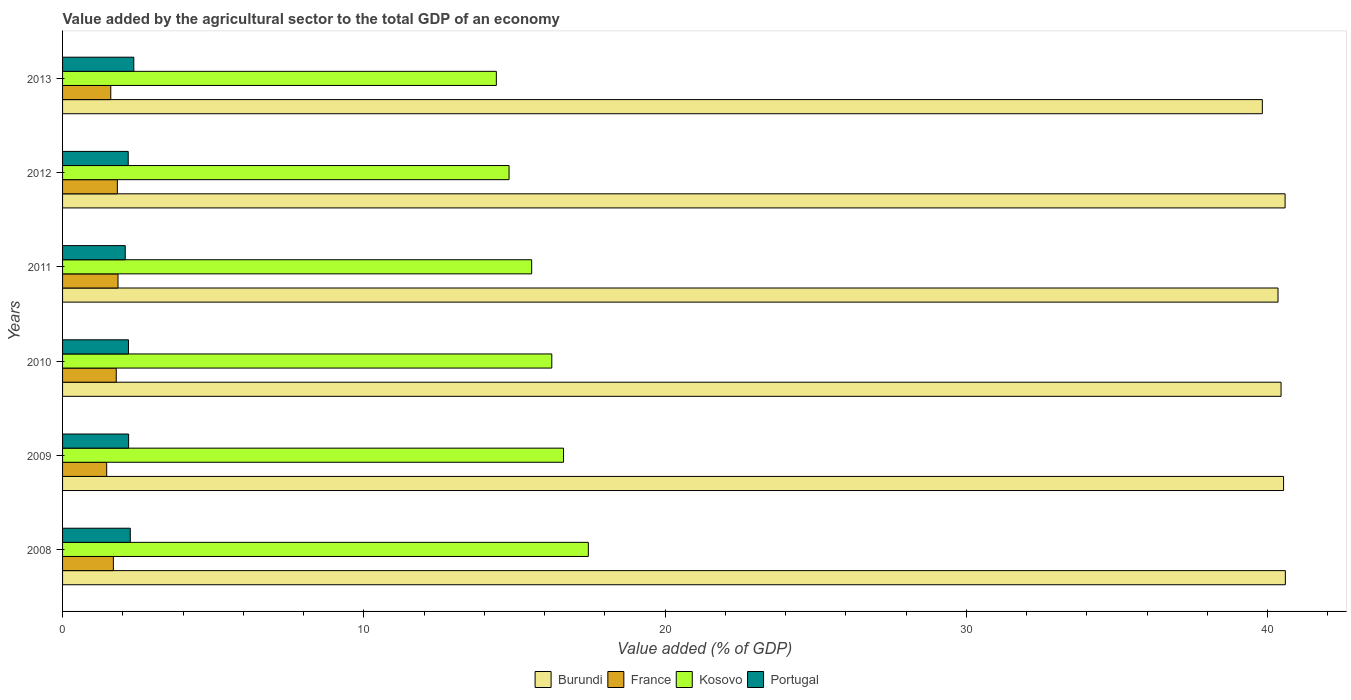How many groups of bars are there?
Give a very brief answer. 6. Are the number of bars on each tick of the Y-axis equal?
Your answer should be very brief. Yes. How many bars are there on the 4th tick from the bottom?
Your answer should be very brief. 4. In how many cases, is the number of bars for a given year not equal to the number of legend labels?
Offer a very short reply. 0. What is the value added by the agricultural sector to the total GDP in France in 2012?
Give a very brief answer. 1.82. Across all years, what is the maximum value added by the agricultural sector to the total GDP in France?
Give a very brief answer. 1.84. Across all years, what is the minimum value added by the agricultural sector to the total GDP in Portugal?
Keep it short and to the point. 2.08. What is the total value added by the agricultural sector to the total GDP in France in the graph?
Keep it short and to the point. 10.19. What is the difference between the value added by the agricultural sector to the total GDP in France in 2010 and that in 2012?
Keep it short and to the point. -0.04. What is the difference between the value added by the agricultural sector to the total GDP in Kosovo in 2010 and the value added by the agricultural sector to the total GDP in Burundi in 2013?
Give a very brief answer. -23.59. What is the average value added by the agricultural sector to the total GDP in Kosovo per year?
Provide a succinct answer. 15.85. In the year 2009, what is the difference between the value added by the agricultural sector to the total GDP in France and value added by the agricultural sector to the total GDP in Kosovo?
Your answer should be very brief. -15.17. In how many years, is the value added by the agricultural sector to the total GDP in Portugal greater than 8 %?
Your answer should be very brief. 0. What is the ratio of the value added by the agricultural sector to the total GDP in Kosovo in 2011 to that in 2012?
Ensure brevity in your answer.  1.05. Is the difference between the value added by the agricultural sector to the total GDP in France in 2008 and 2009 greater than the difference between the value added by the agricultural sector to the total GDP in Kosovo in 2008 and 2009?
Make the answer very short. No. What is the difference between the highest and the second highest value added by the agricultural sector to the total GDP in France?
Keep it short and to the point. 0.02. What is the difference between the highest and the lowest value added by the agricultural sector to the total GDP in France?
Provide a short and direct response. 0.38. In how many years, is the value added by the agricultural sector to the total GDP in Burundi greater than the average value added by the agricultural sector to the total GDP in Burundi taken over all years?
Provide a short and direct response. 4. Is the sum of the value added by the agricultural sector to the total GDP in Kosovo in 2009 and 2010 greater than the maximum value added by the agricultural sector to the total GDP in Portugal across all years?
Make the answer very short. Yes. What does the 4th bar from the top in 2013 represents?
Your answer should be compact. Burundi. Is it the case that in every year, the sum of the value added by the agricultural sector to the total GDP in Portugal and value added by the agricultural sector to the total GDP in France is greater than the value added by the agricultural sector to the total GDP in Burundi?
Your response must be concise. No. How many bars are there?
Keep it short and to the point. 24. How many years are there in the graph?
Provide a succinct answer. 6. What is the difference between two consecutive major ticks on the X-axis?
Give a very brief answer. 10. Does the graph contain any zero values?
Make the answer very short. No. How are the legend labels stacked?
Provide a short and direct response. Horizontal. What is the title of the graph?
Your response must be concise. Value added by the agricultural sector to the total GDP of an economy. Does "St. Vincent and the Grenadines" appear as one of the legend labels in the graph?
Provide a short and direct response. No. What is the label or title of the X-axis?
Ensure brevity in your answer.  Value added (% of GDP). What is the Value added (% of GDP) in Burundi in 2008?
Ensure brevity in your answer.  40.59. What is the Value added (% of GDP) in France in 2008?
Provide a short and direct response. 1.69. What is the Value added (% of GDP) in Kosovo in 2008?
Make the answer very short. 17.45. What is the Value added (% of GDP) of Portugal in 2008?
Your answer should be compact. 2.25. What is the Value added (% of GDP) in Burundi in 2009?
Make the answer very short. 40.53. What is the Value added (% of GDP) in France in 2009?
Ensure brevity in your answer.  1.46. What is the Value added (% of GDP) of Kosovo in 2009?
Give a very brief answer. 16.63. What is the Value added (% of GDP) of Portugal in 2009?
Provide a short and direct response. 2.19. What is the Value added (% of GDP) in Burundi in 2010?
Offer a terse response. 40.45. What is the Value added (% of GDP) in France in 2010?
Keep it short and to the point. 1.78. What is the Value added (% of GDP) of Kosovo in 2010?
Your response must be concise. 16.24. What is the Value added (% of GDP) of Portugal in 2010?
Provide a succinct answer. 2.19. What is the Value added (% of GDP) of Burundi in 2011?
Ensure brevity in your answer.  40.35. What is the Value added (% of GDP) in France in 2011?
Offer a terse response. 1.84. What is the Value added (% of GDP) in Kosovo in 2011?
Keep it short and to the point. 15.57. What is the Value added (% of GDP) in Portugal in 2011?
Keep it short and to the point. 2.08. What is the Value added (% of GDP) of Burundi in 2012?
Offer a very short reply. 40.58. What is the Value added (% of GDP) in France in 2012?
Provide a succinct answer. 1.82. What is the Value added (% of GDP) in Kosovo in 2012?
Give a very brief answer. 14.82. What is the Value added (% of GDP) in Portugal in 2012?
Keep it short and to the point. 2.18. What is the Value added (% of GDP) in Burundi in 2013?
Make the answer very short. 39.83. What is the Value added (% of GDP) in France in 2013?
Keep it short and to the point. 1.6. What is the Value added (% of GDP) of Kosovo in 2013?
Your answer should be very brief. 14.4. What is the Value added (% of GDP) of Portugal in 2013?
Your answer should be very brief. 2.37. Across all years, what is the maximum Value added (% of GDP) in Burundi?
Provide a short and direct response. 40.59. Across all years, what is the maximum Value added (% of GDP) in France?
Ensure brevity in your answer.  1.84. Across all years, what is the maximum Value added (% of GDP) of Kosovo?
Provide a succinct answer. 17.45. Across all years, what is the maximum Value added (% of GDP) of Portugal?
Keep it short and to the point. 2.37. Across all years, what is the minimum Value added (% of GDP) in Burundi?
Offer a very short reply. 39.83. Across all years, what is the minimum Value added (% of GDP) of France?
Make the answer very short. 1.46. Across all years, what is the minimum Value added (% of GDP) of Kosovo?
Offer a very short reply. 14.4. Across all years, what is the minimum Value added (% of GDP) of Portugal?
Make the answer very short. 2.08. What is the total Value added (% of GDP) of Burundi in the graph?
Offer a terse response. 242.33. What is the total Value added (% of GDP) of France in the graph?
Offer a terse response. 10.19. What is the total Value added (% of GDP) in Kosovo in the graph?
Make the answer very short. 95.12. What is the total Value added (% of GDP) in Portugal in the graph?
Keep it short and to the point. 13.25. What is the difference between the Value added (% of GDP) of Burundi in 2008 and that in 2009?
Give a very brief answer. 0.06. What is the difference between the Value added (% of GDP) of France in 2008 and that in 2009?
Ensure brevity in your answer.  0.22. What is the difference between the Value added (% of GDP) of Kosovo in 2008 and that in 2009?
Your answer should be compact. 0.82. What is the difference between the Value added (% of GDP) in Portugal in 2008 and that in 2009?
Keep it short and to the point. 0.06. What is the difference between the Value added (% of GDP) of Burundi in 2008 and that in 2010?
Offer a very short reply. 0.14. What is the difference between the Value added (% of GDP) in France in 2008 and that in 2010?
Offer a very short reply. -0.1. What is the difference between the Value added (% of GDP) in Kosovo in 2008 and that in 2010?
Ensure brevity in your answer.  1.21. What is the difference between the Value added (% of GDP) of Portugal in 2008 and that in 2010?
Keep it short and to the point. 0.06. What is the difference between the Value added (% of GDP) in Burundi in 2008 and that in 2011?
Provide a succinct answer. 0.24. What is the difference between the Value added (% of GDP) of France in 2008 and that in 2011?
Ensure brevity in your answer.  -0.15. What is the difference between the Value added (% of GDP) in Kosovo in 2008 and that in 2011?
Provide a short and direct response. 1.88. What is the difference between the Value added (% of GDP) in Portugal in 2008 and that in 2011?
Provide a succinct answer. 0.17. What is the difference between the Value added (% of GDP) of Burundi in 2008 and that in 2012?
Provide a succinct answer. 0.01. What is the difference between the Value added (% of GDP) in France in 2008 and that in 2012?
Ensure brevity in your answer.  -0.13. What is the difference between the Value added (% of GDP) in Kosovo in 2008 and that in 2012?
Offer a terse response. 2.63. What is the difference between the Value added (% of GDP) of Portugal in 2008 and that in 2012?
Give a very brief answer. 0.07. What is the difference between the Value added (% of GDP) in Burundi in 2008 and that in 2013?
Make the answer very short. 0.76. What is the difference between the Value added (% of GDP) of France in 2008 and that in 2013?
Your answer should be very brief. 0.09. What is the difference between the Value added (% of GDP) in Kosovo in 2008 and that in 2013?
Give a very brief answer. 3.05. What is the difference between the Value added (% of GDP) of Portugal in 2008 and that in 2013?
Keep it short and to the point. -0.12. What is the difference between the Value added (% of GDP) of Burundi in 2009 and that in 2010?
Your answer should be compact. 0.08. What is the difference between the Value added (% of GDP) of France in 2009 and that in 2010?
Your answer should be very brief. -0.32. What is the difference between the Value added (% of GDP) in Kosovo in 2009 and that in 2010?
Provide a short and direct response. 0.39. What is the difference between the Value added (% of GDP) in Portugal in 2009 and that in 2010?
Give a very brief answer. 0. What is the difference between the Value added (% of GDP) of Burundi in 2009 and that in 2011?
Offer a terse response. 0.18. What is the difference between the Value added (% of GDP) of France in 2009 and that in 2011?
Ensure brevity in your answer.  -0.38. What is the difference between the Value added (% of GDP) of Kosovo in 2009 and that in 2011?
Your answer should be very brief. 1.06. What is the difference between the Value added (% of GDP) of Portugal in 2009 and that in 2011?
Ensure brevity in your answer.  0.11. What is the difference between the Value added (% of GDP) in Burundi in 2009 and that in 2012?
Give a very brief answer. -0.05. What is the difference between the Value added (% of GDP) of France in 2009 and that in 2012?
Your response must be concise. -0.35. What is the difference between the Value added (% of GDP) in Kosovo in 2009 and that in 2012?
Your answer should be very brief. 1.81. What is the difference between the Value added (% of GDP) of Portugal in 2009 and that in 2012?
Provide a short and direct response. 0.01. What is the difference between the Value added (% of GDP) of Burundi in 2009 and that in 2013?
Provide a succinct answer. 0.7. What is the difference between the Value added (% of GDP) of France in 2009 and that in 2013?
Your response must be concise. -0.14. What is the difference between the Value added (% of GDP) in Kosovo in 2009 and that in 2013?
Provide a succinct answer. 2.23. What is the difference between the Value added (% of GDP) of Portugal in 2009 and that in 2013?
Your answer should be compact. -0.17. What is the difference between the Value added (% of GDP) of Burundi in 2010 and that in 2011?
Offer a very short reply. 0.1. What is the difference between the Value added (% of GDP) in France in 2010 and that in 2011?
Offer a terse response. -0.06. What is the difference between the Value added (% of GDP) in Kosovo in 2010 and that in 2011?
Your answer should be very brief. 0.67. What is the difference between the Value added (% of GDP) in Portugal in 2010 and that in 2011?
Keep it short and to the point. 0.11. What is the difference between the Value added (% of GDP) in Burundi in 2010 and that in 2012?
Your answer should be compact. -0.13. What is the difference between the Value added (% of GDP) of France in 2010 and that in 2012?
Make the answer very short. -0.04. What is the difference between the Value added (% of GDP) in Kosovo in 2010 and that in 2012?
Give a very brief answer. 1.42. What is the difference between the Value added (% of GDP) of Portugal in 2010 and that in 2012?
Your answer should be very brief. 0.01. What is the difference between the Value added (% of GDP) of Burundi in 2010 and that in 2013?
Provide a succinct answer. 0.62. What is the difference between the Value added (% of GDP) in France in 2010 and that in 2013?
Ensure brevity in your answer.  0.18. What is the difference between the Value added (% of GDP) of Kosovo in 2010 and that in 2013?
Your answer should be very brief. 1.84. What is the difference between the Value added (% of GDP) of Portugal in 2010 and that in 2013?
Make the answer very short. -0.18. What is the difference between the Value added (% of GDP) in Burundi in 2011 and that in 2012?
Give a very brief answer. -0.23. What is the difference between the Value added (% of GDP) in France in 2011 and that in 2012?
Your answer should be very brief. 0.02. What is the difference between the Value added (% of GDP) of Kosovo in 2011 and that in 2012?
Provide a short and direct response. 0.75. What is the difference between the Value added (% of GDP) of Portugal in 2011 and that in 2012?
Ensure brevity in your answer.  -0.1. What is the difference between the Value added (% of GDP) in Burundi in 2011 and that in 2013?
Offer a terse response. 0.52. What is the difference between the Value added (% of GDP) of France in 2011 and that in 2013?
Make the answer very short. 0.24. What is the difference between the Value added (% of GDP) of Kosovo in 2011 and that in 2013?
Ensure brevity in your answer.  1.17. What is the difference between the Value added (% of GDP) in Portugal in 2011 and that in 2013?
Give a very brief answer. -0.28. What is the difference between the Value added (% of GDP) of Burundi in 2012 and that in 2013?
Make the answer very short. 0.76. What is the difference between the Value added (% of GDP) of France in 2012 and that in 2013?
Offer a terse response. 0.22. What is the difference between the Value added (% of GDP) in Kosovo in 2012 and that in 2013?
Ensure brevity in your answer.  0.42. What is the difference between the Value added (% of GDP) of Portugal in 2012 and that in 2013?
Keep it short and to the point. -0.19. What is the difference between the Value added (% of GDP) of Burundi in 2008 and the Value added (% of GDP) of France in 2009?
Make the answer very short. 39.13. What is the difference between the Value added (% of GDP) of Burundi in 2008 and the Value added (% of GDP) of Kosovo in 2009?
Ensure brevity in your answer.  23.96. What is the difference between the Value added (% of GDP) of Burundi in 2008 and the Value added (% of GDP) of Portugal in 2009?
Your answer should be very brief. 38.4. What is the difference between the Value added (% of GDP) of France in 2008 and the Value added (% of GDP) of Kosovo in 2009?
Offer a very short reply. -14.94. What is the difference between the Value added (% of GDP) of France in 2008 and the Value added (% of GDP) of Portugal in 2009?
Your answer should be very brief. -0.51. What is the difference between the Value added (% of GDP) of Kosovo in 2008 and the Value added (% of GDP) of Portugal in 2009?
Make the answer very short. 15.26. What is the difference between the Value added (% of GDP) of Burundi in 2008 and the Value added (% of GDP) of France in 2010?
Keep it short and to the point. 38.81. What is the difference between the Value added (% of GDP) in Burundi in 2008 and the Value added (% of GDP) in Kosovo in 2010?
Offer a very short reply. 24.35. What is the difference between the Value added (% of GDP) in Burundi in 2008 and the Value added (% of GDP) in Portugal in 2010?
Keep it short and to the point. 38.4. What is the difference between the Value added (% of GDP) of France in 2008 and the Value added (% of GDP) of Kosovo in 2010?
Ensure brevity in your answer.  -14.55. What is the difference between the Value added (% of GDP) in France in 2008 and the Value added (% of GDP) in Portugal in 2010?
Make the answer very short. -0.5. What is the difference between the Value added (% of GDP) in Kosovo in 2008 and the Value added (% of GDP) in Portugal in 2010?
Offer a very short reply. 15.27. What is the difference between the Value added (% of GDP) of Burundi in 2008 and the Value added (% of GDP) of France in 2011?
Keep it short and to the point. 38.75. What is the difference between the Value added (% of GDP) of Burundi in 2008 and the Value added (% of GDP) of Kosovo in 2011?
Provide a short and direct response. 25.02. What is the difference between the Value added (% of GDP) of Burundi in 2008 and the Value added (% of GDP) of Portugal in 2011?
Give a very brief answer. 38.51. What is the difference between the Value added (% of GDP) of France in 2008 and the Value added (% of GDP) of Kosovo in 2011?
Offer a very short reply. -13.89. What is the difference between the Value added (% of GDP) in France in 2008 and the Value added (% of GDP) in Portugal in 2011?
Your response must be concise. -0.39. What is the difference between the Value added (% of GDP) in Kosovo in 2008 and the Value added (% of GDP) in Portugal in 2011?
Ensure brevity in your answer.  15.37. What is the difference between the Value added (% of GDP) of Burundi in 2008 and the Value added (% of GDP) of France in 2012?
Offer a terse response. 38.77. What is the difference between the Value added (% of GDP) of Burundi in 2008 and the Value added (% of GDP) of Kosovo in 2012?
Make the answer very short. 25.77. What is the difference between the Value added (% of GDP) in Burundi in 2008 and the Value added (% of GDP) in Portugal in 2012?
Keep it short and to the point. 38.41. What is the difference between the Value added (% of GDP) in France in 2008 and the Value added (% of GDP) in Kosovo in 2012?
Offer a terse response. -13.13. What is the difference between the Value added (% of GDP) of France in 2008 and the Value added (% of GDP) of Portugal in 2012?
Your response must be concise. -0.49. What is the difference between the Value added (% of GDP) of Kosovo in 2008 and the Value added (% of GDP) of Portugal in 2012?
Offer a terse response. 15.27. What is the difference between the Value added (% of GDP) of Burundi in 2008 and the Value added (% of GDP) of France in 2013?
Provide a succinct answer. 38.99. What is the difference between the Value added (% of GDP) of Burundi in 2008 and the Value added (% of GDP) of Kosovo in 2013?
Ensure brevity in your answer.  26.19. What is the difference between the Value added (% of GDP) of Burundi in 2008 and the Value added (% of GDP) of Portugal in 2013?
Offer a very short reply. 38.23. What is the difference between the Value added (% of GDP) of France in 2008 and the Value added (% of GDP) of Kosovo in 2013?
Give a very brief answer. -12.71. What is the difference between the Value added (% of GDP) of France in 2008 and the Value added (% of GDP) of Portugal in 2013?
Offer a very short reply. -0.68. What is the difference between the Value added (% of GDP) in Kosovo in 2008 and the Value added (% of GDP) in Portugal in 2013?
Make the answer very short. 15.09. What is the difference between the Value added (% of GDP) in Burundi in 2009 and the Value added (% of GDP) in France in 2010?
Your answer should be very brief. 38.75. What is the difference between the Value added (% of GDP) of Burundi in 2009 and the Value added (% of GDP) of Kosovo in 2010?
Keep it short and to the point. 24.29. What is the difference between the Value added (% of GDP) in Burundi in 2009 and the Value added (% of GDP) in Portugal in 2010?
Provide a short and direct response. 38.34. What is the difference between the Value added (% of GDP) in France in 2009 and the Value added (% of GDP) in Kosovo in 2010?
Keep it short and to the point. -14.78. What is the difference between the Value added (% of GDP) in France in 2009 and the Value added (% of GDP) in Portugal in 2010?
Your response must be concise. -0.72. What is the difference between the Value added (% of GDP) in Kosovo in 2009 and the Value added (% of GDP) in Portugal in 2010?
Your answer should be very brief. 14.44. What is the difference between the Value added (% of GDP) in Burundi in 2009 and the Value added (% of GDP) in France in 2011?
Your answer should be very brief. 38.69. What is the difference between the Value added (% of GDP) in Burundi in 2009 and the Value added (% of GDP) in Kosovo in 2011?
Provide a short and direct response. 24.96. What is the difference between the Value added (% of GDP) in Burundi in 2009 and the Value added (% of GDP) in Portugal in 2011?
Ensure brevity in your answer.  38.45. What is the difference between the Value added (% of GDP) of France in 2009 and the Value added (% of GDP) of Kosovo in 2011?
Provide a short and direct response. -14.11. What is the difference between the Value added (% of GDP) in France in 2009 and the Value added (% of GDP) in Portugal in 2011?
Offer a very short reply. -0.62. What is the difference between the Value added (% of GDP) of Kosovo in 2009 and the Value added (% of GDP) of Portugal in 2011?
Give a very brief answer. 14.55. What is the difference between the Value added (% of GDP) in Burundi in 2009 and the Value added (% of GDP) in France in 2012?
Offer a terse response. 38.71. What is the difference between the Value added (% of GDP) in Burundi in 2009 and the Value added (% of GDP) in Kosovo in 2012?
Your answer should be compact. 25.71. What is the difference between the Value added (% of GDP) of Burundi in 2009 and the Value added (% of GDP) of Portugal in 2012?
Offer a very short reply. 38.35. What is the difference between the Value added (% of GDP) in France in 2009 and the Value added (% of GDP) in Kosovo in 2012?
Your response must be concise. -13.36. What is the difference between the Value added (% of GDP) of France in 2009 and the Value added (% of GDP) of Portugal in 2012?
Make the answer very short. -0.71. What is the difference between the Value added (% of GDP) of Kosovo in 2009 and the Value added (% of GDP) of Portugal in 2012?
Ensure brevity in your answer.  14.45. What is the difference between the Value added (% of GDP) of Burundi in 2009 and the Value added (% of GDP) of France in 2013?
Your answer should be compact. 38.93. What is the difference between the Value added (% of GDP) in Burundi in 2009 and the Value added (% of GDP) in Kosovo in 2013?
Your answer should be compact. 26.13. What is the difference between the Value added (% of GDP) in Burundi in 2009 and the Value added (% of GDP) in Portugal in 2013?
Ensure brevity in your answer.  38.17. What is the difference between the Value added (% of GDP) of France in 2009 and the Value added (% of GDP) of Kosovo in 2013?
Provide a succinct answer. -12.93. What is the difference between the Value added (% of GDP) of France in 2009 and the Value added (% of GDP) of Portugal in 2013?
Offer a terse response. -0.9. What is the difference between the Value added (% of GDP) of Kosovo in 2009 and the Value added (% of GDP) of Portugal in 2013?
Provide a short and direct response. 14.26. What is the difference between the Value added (% of GDP) in Burundi in 2010 and the Value added (% of GDP) in France in 2011?
Keep it short and to the point. 38.61. What is the difference between the Value added (% of GDP) in Burundi in 2010 and the Value added (% of GDP) in Kosovo in 2011?
Make the answer very short. 24.88. What is the difference between the Value added (% of GDP) of Burundi in 2010 and the Value added (% of GDP) of Portugal in 2011?
Ensure brevity in your answer.  38.37. What is the difference between the Value added (% of GDP) of France in 2010 and the Value added (% of GDP) of Kosovo in 2011?
Offer a very short reply. -13.79. What is the difference between the Value added (% of GDP) in France in 2010 and the Value added (% of GDP) in Portugal in 2011?
Give a very brief answer. -0.3. What is the difference between the Value added (% of GDP) in Kosovo in 2010 and the Value added (% of GDP) in Portugal in 2011?
Give a very brief answer. 14.16. What is the difference between the Value added (% of GDP) of Burundi in 2010 and the Value added (% of GDP) of France in 2012?
Provide a succinct answer. 38.63. What is the difference between the Value added (% of GDP) in Burundi in 2010 and the Value added (% of GDP) in Kosovo in 2012?
Ensure brevity in your answer.  25.63. What is the difference between the Value added (% of GDP) in Burundi in 2010 and the Value added (% of GDP) in Portugal in 2012?
Ensure brevity in your answer.  38.27. What is the difference between the Value added (% of GDP) of France in 2010 and the Value added (% of GDP) of Kosovo in 2012?
Your response must be concise. -13.04. What is the difference between the Value added (% of GDP) of France in 2010 and the Value added (% of GDP) of Portugal in 2012?
Your answer should be compact. -0.4. What is the difference between the Value added (% of GDP) in Kosovo in 2010 and the Value added (% of GDP) in Portugal in 2012?
Offer a terse response. 14.06. What is the difference between the Value added (% of GDP) in Burundi in 2010 and the Value added (% of GDP) in France in 2013?
Offer a very short reply. 38.85. What is the difference between the Value added (% of GDP) of Burundi in 2010 and the Value added (% of GDP) of Kosovo in 2013?
Ensure brevity in your answer.  26.05. What is the difference between the Value added (% of GDP) of Burundi in 2010 and the Value added (% of GDP) of Portugal in 2013?
Ensure brevity in your answer.  38.08. What is the difference between the Value added (% of GDP) in France in 2010 and the Value added (% of GDP) in Kosovo in 2013?
Provide a succinct answer. -12.62. What is the difference between the Value added (% of GDP) of France in 2010 and the Value added (% of GDP) of Portugal in 2013?
Keep it short and to the point. -0.58. What is the difference between the Value added (% of GDP) in Kosovo in 2010 and the Value added (% of GDP) in Portugal in 2013?
Ensure brevity in your answer.  13.88. What is the difference between the Value added (% of GDP) of Burundi in 2011 and the Value added (% of GDP) of France in 2012?
Ensure brevity in your answer.  38.53. What is the difference between the Value added (% of GDP) of Burundi in 2011 and the Value added (% of GDP) of Kosovo in 2012?
Give a very brief answer. 25.53. What is the difference between the Value added (% of GDP) in Burundi in 2011 and the Value added (% of GDP) in Portugal in 2012?
Make the answer very short. 38.17. What is the difference between the Value added (% of GDP) of France in 2011 and the Value added (% of GDP) of Kosovo in 2012?
Provide a succinct answer. -12.98. What is the difference between the Value added (% of GDP) of France in 2011 and the Value added (% of GDP) of Portugal in 2012?
Ensure brevity in your answer.  -0.34. What is the difference between the Value added (% of GDP) of Kosovo in 2011 and the Value added (% of GDP) of Portugal in 2012?
Give a very brief answer. 13.39. What is the difference between the Value added (% of GDP) in Burundi in 2011 and the Value added (% of GDP) in France in 2013?
Your answer should be very brief. 38.75. What is the difference between the Value added (% of GDP) of Burundi in 2011 and the Value added (% of GDP) of Kosovo in 2013?
Ensure brevity in your answer.  25.95. What is the difference between the Value added (% of GDP) in Burundi in 2011 and the Value added (% of GDP) in Portugal in 2013?
Keep it short and to the point. 37.98. What is the difference between the Value added (% of GDP) in France in 2011 and the Value added (% of GDP) in Kosovo in 2013?
Keep it short and to the point. -12.56. What is the difference between the Value added (% of GDP) in France in 2011 and the Value added (% of GDP) in Portugal in 2013?
Offer a very short reply. -0.52. What is the difference between the Value added (% of GDP) of Kosovo in 2011 and the Value added (% of GDP) of Portugal in 2013?
Your answer should be compact. 13.21. What is the difference between the Value added (% of GDP) in Burundi in 2012 and the Value added (% of GDP) in France in 2013?
Give a very brief answer. 38.98. What is the difference between the Value added (% of GDP) in Burundi in 2012 and the Value added (% of GDP) in Kosovo in 2013?
Make the answer very short. 26.18. What is the difference between the Value added (% of GDP) in Burundi in 2012 and the Value added (% of GDP) in Portugal in 2013?
Your answer should be very brief. 38.22. What is the difference between the Value added (% of GDP) in France in 2012 and the Value added (% of GDP) in Kosovo in 2013?
Make the answer very short. -12.58. What is the difference between the Value added (% of GDP) in France in 2012 and the Value added (% of GDP) in Portugal in 2013?
Ensure brevity in your answer.  -0.55. What is the difference between the Value added (% of GDP) of Kosovo in 2012 and the Value added (% of GDP) of Portugal in 2013?
Make the answer very short. 12.46. What is the average Value added (% of GDP) in Burundi per year?
Keep it short and to the point. 40.39. What is the average Value added (% of GDP) in France per year?
Offer a very short reply. 1.7. What is the average Value added (% of GDP) in Kosovo per year?
Provide a short and direct response. 15.85. What is the average Value added (% of GDP) in Portugal per year?
Provide a succinct answer. 2.21. In the year 2008, what is the difference between the Value added (% of GDP) in Burundi and Value added (% of GDP) in France?
Provide a short and direct response. 38.9. In the year 2008, what is the difference between the Value added (% of GDP) of Burundi and Value added (% of GDP) of Kosovo?
Provide a succinct answer. 23.14. In the year 2008, what is the difference between the Value added (% of GDP) of Burundi and Value added (% of GDP) of Portugal?
Make the answer very short. 38.34. In the year 2008, what is the difference between the Value added (% of GDP) of France and Value added (% of GDP) of Kosovo?
Your answer should be compact. -15.77. In the year 2008, what is the difference between the Value added (% of GDP) of France and Value added (% of GDP) of Portugal?
Make the answer very short. -0.56. In the year 2008, what is the difference between the Value added (% of GDP) in Kosovo and Value added (% of GDP) in Portugal?
Provide a succinct answer. 15.21. In the year 2009, what is the difference between the Value added (% of GDP) in Burundi and Value added (% of GDP) in France?
Ensure brevity in your answer.  39.07. In the year 2009, what is the difference between the Value added (% of GDP) of Burundi and Value added (% of GDP) of Kosovo?
Provide a short and direct response. 23.9. In the year 2009, what is the difference between the Value added (% of GDP) in Burundi and Value added (% of GDP) in Portugal?
Give a very brief answer. 38.34. In the year 2009, what is the difference between the Value added (% of GDP) of France and Value added (% of GDP) of Kosovo?
Give a very brief answer. -15.17. In the year 2009, what is the difference between the Value added (% of GDP) of France and Value added (% of GDP) of Portugal?
Offer a terse response. -0.73. In the year 2009, what is the difference between the Value added (% of GDP) of Kosovo and Value added (% of GDP) of Portugal?
Your answer should be very brief. 14.44. In the year 2010, what is the difference between the Value added (% of GDP) in Burundi and Value added (% of GDP) in France?
Your answer should be compact. 38.67. In the year 2010, what is the difference between the Value added (% of GDP) in Burundi and Value added (% of GDP) in Kosovo?
Offer a very short reply. 24.21. In the year 2010, what is the difference between the Value added (% of GDP) of Burundi and Value added (% of GDP) of Portugal?
Offer a very short reply. 38.26. In the year 2010, what is the difference between the Value added (% of GDP) of France and Value added (% of GDP) of Kosovo?
Keep it short and to the point. -14.46. In the year 2010, what is the difference between the Value added (% of GDP) of France and Value added (% of GDP) of Portugal?
Make the answer very short. -0.41. In the year 2010, what is the difference between the Value added (% of GDP) of Kosovo and Value added (% of GDP) of Portugal?
Give a very brief answer. 14.05. In the year 2011, what is the difference between the Value added (% of GDP) of Burundi and Value added (% of GDP) of France?
Offer a terse response. 38.51. In the year 2011, what is the difference between the Value added (% of GDP) of Burundi and Value added (% of GDP) of Kosovo?
Make the answer very short. 24.78. In the year 2011, what is the difference between the Value added (% of GDP) of Burundi and Value added (% of GDP) of Portugal?
Ensure brevity in your answer.  38.27. In the year 2011, what is the difference between the Value added (% of GDP) of France and Value added (% of GDP) of Kosovo?
Your answer should be very brief. -13.73. In the year 2011, what is the difference between the Value added (% of GDP) in France and Value added (% of GDP) in Portugal?
Make the answer very short. -0.24. In the year 2011, what is the difference between the Value added (% of GDP) of Kosovo and Value added (% of GDP) of Portugal?
Provide a short and direct response. 13.49. In the year 2012, what is the difference between the Value added (% of GDP) in Burundi and Value added (% of GDP) in France?
Provide a succinct answer. 38.76. In the year 2012, what is the difference between the Value added (% of GDP) of Burundi and Value added (% of GDP) of Kosovo?
Provide a succinct answer. 25.76. In the year 2012, what is the difference between the Value added (% of GDP) of Burundi and Value added (% of GDP) of Portugal?
Keep it short and to the point. 38.4. In the year 2012, what is the difference between the Value added (% of GDP) of France and Value added (% of GDP) of Kosovo?
Make the answer very short. -13. In the year 2012, what is the difference between the Value added (% of GDP) of France and Value added (% of GDP) of Portugal?
Offer a terse response. -0.36. In the year 2012, what is the difference between the Value added (% of GDP) of Kosovo and Value added (% of GDP) of Portugal?
Provide a succinct answer. 12.64. In the year 2013, what is the difference between the Value added (% of GDP) in Burundi and Value added (% of GDP) in France?
Provide a succinct answer. 38.23. In the year 2013, what is the difference between the Value added (% of GDP) of Burundi and Value added (% of GDP) of Kosovo?
Keep it short and to the point. 25.43. In the year 2013, what is the difference between the Value added (% of GDP) in Burundi and Value added (% of GDP) in Portugal?
Ensure brevity in your answer.  37.46. In the year 2013, what is the difference between the Value added (% of GDP) in France and Value added (% of GDP) in Kosovo?
Your answer should be very brief. -12.8. In the year 2013, what is the difference between the Value added (% of GDP) in France and Value added (% of GDP) in Portugal?
Ensure brevity in your answer.  -0.77. In the year 2013, what is the difference between the Value added (% of GDP) of Kosovo and Value added (% of GDP) of Portugal?
Give a very brief answer. 12.03. What is the ratio of the Value added (% of GDP) in France in 2008 to that in 2009?
Your response must be concise. 1.15. What is the ratio of the Value added (% of GDP) of Kosovo in 2008 to that in 2009?
Your answer should be very brief. 1.05. What is the ratio of the Value added (% of GDP) in Portugal in 2008 to that in 2009?
Offer a very short reply. 1.03. What is the ratio of the Value added (% of GDP) in France in 2008 to that in 2010?
Make the answer very short. 0.95. What is the ratio of the Value added (% of GDP) of Kosovo in 2008 to that in 2010?
Your answer should be compact. 1.07. What is the ratio of the Value added (% of GDP) of Portugal in 2008 to that in 2010?
Provide a succinct answer. 1.03. What is the ratio of the Value added (% of GDP) of Burundi in 2008 to that in 2011?
Provide a short and direct response. 1.01. What is the ratio of the Value added (% of GDP) of France in 2008 to that in 2011?
Offer a terse response. 0.92. What is the ratio of the Value added (% of GDP) of Kosovo in 2008 to that in 2011?
Offer a very short reply. 1.12. What is the ratio of the Value added (% of GDP) in Portugal in 2008 to that in 2011?
Ensure brevity in your answer.  1.08. What is the ratio of the Value added (% of GDP) in France in 2008 to that in 2012?
Give a very brief answer. 0.93. What is the ratio of the Value added (% of GDP) of Kosovo in 2008 to that in 2012?
Offer a very short reply. 1.18. What is the ratio of the Value added (% of GDP) of Portugal in 2008 to that in 2012?
Give a very brief answer. 1.03. What is the ratio of the Value added (% of GDP) in Burundi in 2008 to that in 2013?
Your answer should be compact. 1.02. What is the ratio of the Value added (% of GDP) of France in 2008 to that in 2013?
Make the answer very short. 1.05. What is the ratio of the Value added (% of GDP) of Kosovo in 2008 to that in 2013?
Provide a succinct answer. 1.21. What is the ratio of the Value added (% of GDP) of Portugal in 2008 to that in 2013?
Make the answer very short. 0.95. What is the ratio of the Value added (% of GDP) of Burundi in 2009 to that in 2010?
Provide a succinct answer. 1. What is the ratio of the Value added (% of GDP) of France in 2009 to that in 2010?
Your response must be concise. 0.82. What is the ratio of the Value added (% of GDP) of Burundi in 2009 to that in 2011?
Offer a very short reply. 1. What is the ratio of the Value added (% of GDP) of France in 2009 to that in 2011?
Offer a very short reply. 0.8. What is the ratio of the Value added (% of GDP) of Kosovo in 2009 to that in 2011?
Ensure brevity in your answer.  1.07. What is the ratio of the Value added (% of GDP) of Portugal in 2009 to that in 2011?
Your answer should be compact. 1.05. What is the ratio of the Value added (% of GDP) in France in 2009 to that in 2012?
Give a very brief answer. 0.81. What is the ratio of the Value added (% of GDP) of Kosovo in 2009 to that in 2012?
Your response must be concise. 1.12. What is the ratio of the Value added (% of GDP) in Portugal in 2009 to that in 2012?
Keep it short and to the point. 1.01. What is the ratio of the Value added (% of GDP) in Burundi in 2009 to that in 2013?
Offer a terse response. 1.02. What is the ratio of the Value added (% of GDP) of France in 2009 to that in 2013?
Keep it short and to the point. 0.92. What is the ratio of the Value added (% of GDP) in Kosovo in 2009 to that in 2013?
Make the answer very short. 1.15. What is the ratio of the Value added (% of GDP) in Portugal in 2009 to that in 2013?
Offer a very short reply. 0.93. What is the ratio of the Value added (% of GDP) in France in 2010 to that in 2011?
Give a very brief answer. 0.97. What is the ratio of the Value added (% of GDP) in Kosovo in 2010 to that in 2011?
Offer a terse response. 1.04. What is the ratio of the Value added (% of GDP) in Portugal in 2010 to that in 2011?
Offer a terse response. 1.05. What is the ratio of the Value added (% of GDP) in France in 2010 to that in 2012?
Offer a very short reply. 0.98. What is the ratio of the Value added (% of GDP) in Kosovo in 2010 to that in 2012?
Your answer should be compact. 1.1. What is the ratio of the Value added (% of GDP) of Portugal in 2010 to that in 2012?
Give a very brief answer. 1. What is the ratio of the Value added (% of GDP) of Burundi in 2010 to that in 2013?
Your answer should be compact. 1.02. What is the ratio of the Value added (% of GDP) in France in 2010 to that in 2013?
Make the answer very short. 1.11. What is the ratio of the Value added (% of GDP) of Kosovo in 2010 to that in 2013?
Keep it short and to the point. 1.13. What is the ratio of the Value added (% of GDP) in Portugal in 2010 to that in 2013?
Your answer should be compact. 0.92. What is the ratio of the Value added (% of GDP) in France in 2011 to that in 2012?
Keep it short and to the point. 1.01. What is the ratio of the Value added (% of GDP) of Kosovo in 2011 to that in 2012?
Make the answer very short. 1.05. What is the ratio of the Value added (% of GDP) of Portugal in 2011 to that in 2012?
Your answer should be very brief. 0.95. What is the ratio of the Value added (% of GDP) in Burundi in 2011 to that in 2013?
Give a very brief answer. 1.01. What is the ratio of the Value added (% of GDP) of France in 2011 to that in 2013?
Your answer should be very brief. 1.15. What is the ratio of the Value added (% of GDP) of Kosovo in 2011 to that in 2013?
Offer a terse response. 1.08. What is the ratio of the Value added (% of GDP) in Portugal in 2011 to that in 2013?
Keep it short and to the point. 0.88. What is the ratio of the Value added (% of GDP) of Burundi in 2012 to that in 2013?
Make the answer very short. 1.02. What is the ratio of the Value added (% of GDP) in France in 2012 to that in 2013?
Your answer should be compact. 1.14. What is the ratio of the Value added (% of GDP) in Kosovo in 2012 to that in 2013?
Ensure brevity in your answer.  1.03. What is the ratio of the Value added (% of GDP) in Portugal in 2012 to that in 2013?
Make the answer very short. 0.92. What is the difference between the highest and the second highest Value added (% of GDP) in Burundi?
Your response must be concise. 0.01. What is the difference between the highest and the second highest Value added (% of GDP) of France?
Your answer should be very brief. 0.02. What is the difference between the highest and the second highest Value added (% of GDP) in Kosovo?
Keep it short and to the point. 0.82. What is the difference between the highest and the second highest Value added (% of GDP) of Portugal?
Offer a very short reply. 0.12. What is the difference between the highest and the lowest Value added (% of GDP) in Burundi?
Your answer should be very brief. 0.76. What is the difference between the highest and the lowest Value added (% of GDP) of France?
Your response must be concise. 0.38. What is the difference between the highest and the lowest Value added (% of GDP) of Kosovo?
Offer a terse response. 3.05. What is the difference between the highest and the lowest Value added (% of GDP) of Portugal?
Give a very brief answer. 0.28. 